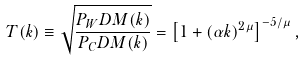<formula> <loc_0><loc_0><loc_500><loc_500>T ( k ) \equiv \sqrt { \frac { P _ { W } D M ( k ) } { P _ { C } D M ( k ) } } = \left [ 1 + ( \alpha k ) ^ { 2 \mu } \right ] ^ { - 5 / \mu } ,</formula> 